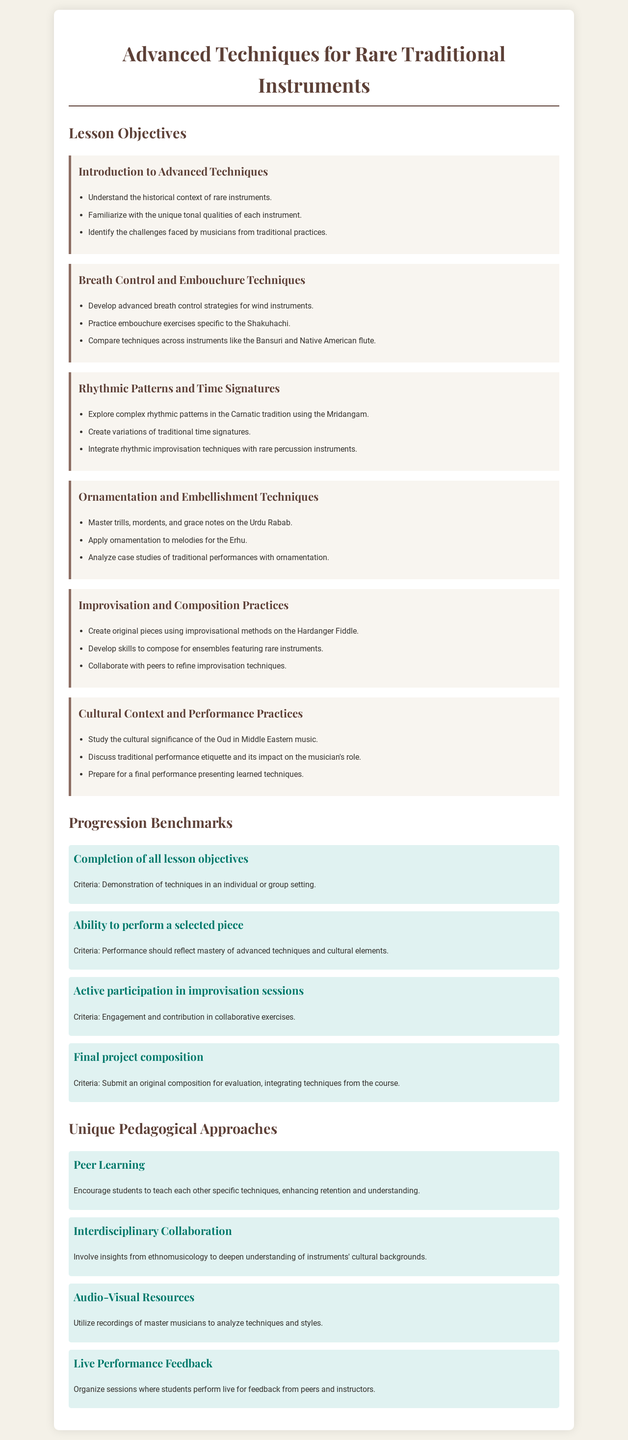What is the title of the document? The title of the document is clearly stated at the top.
Answer: Advanced Techniques for Rare Traditional Instruments How many lessons are there in the curriculum? The document lists multiple lessons under lesson objectives.
Answer: Six What is one of the lesson objectives for breath control techniques? The document specifies individual objectives for each lesson.
Answer: Practice embouchure exercises specific to the Shakuhachi What is the first progression benchmark mentioned? The benchmarks are listed under the Progression Benchmarks section.
Answer: Completion of all lesson objectives Which approach encourages students to teach each other? The document describes several unique pedagogical approaches.
Answer: Peer Learning What instrument is associated with ornamentation and embellishment techniques? The document mentions specific instruments tied to different techniques.
Answer: Urdu Rabab What is the final project criteria? The document lays out specific criteria for the final project.
Answer: Submit an original composition for evaluation, integrating techniques from the course Name one cultural aspect studied in the curriculum. The lesson on cultural context highlights specific cultural elements.
Answer: Cultural significance of the Oud in Middle Eastern music 